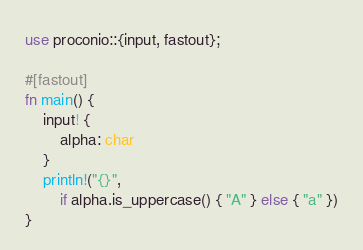<code> <loc_0><loc_0><loc_500><loc_500><_Rust_>use proconio::{input, fastout};

#[fastout]
fn main() {
	input! {
		alpha: char
	}
	println!("{}",
		if alpha.is_uppercase() { "A" } else { "a" })
}</code> 